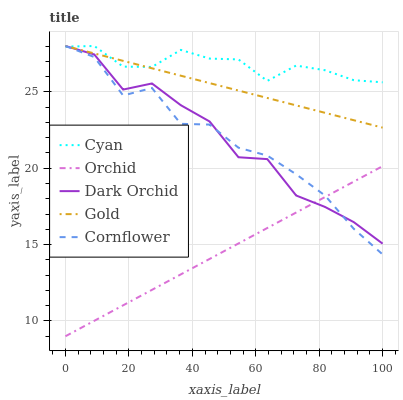Does Orchid have the minimum area under the curve?
Answer yes or no. Yes. Does Cyan have the maximum area under the curve?
Answer yes or no. Yes. Does Cornflower have the minimum area under the curve?
Answer yes or no. No. Does Cornflower have the maximum area under the curve?
Answer yes or no. No. Is Gold the smoothest?
Answer yes or no. Yes. Is Dark Orchid the roughest?
Answer yes or no. Yes. Is Cornflower the smoothest?
Answer yes or no. No. Is Cornflower the roughest?
Answer yes or no. No. Does Orchid have the lowest value?
Answer yes or no. Yes. Does Cornflower have the lowest value?
Answer yes or no. No. Does Dark Orchid have the highest value?
Answer yes or no. Yes. Does Orchid have the highest value?
Answer yes or no. No. Is Orchid less than Cyan?
Answer yes or no. Yes. Is Cyan greater than Orchid?
Answer yes or no. Yes. Does Cyan intersect Gold?
Answer yes or no. Yes. Is Cyan less than Gold?
Answer yes or no. No. Is Cyan greater than Gold?
Answer yes or no. No. Does Orchid intersect Cyan?
Answer yes or no. No. 